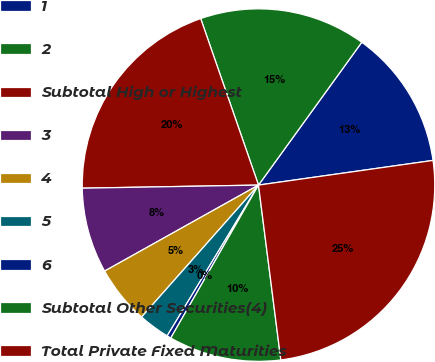Convert chart. <chart><loc_0><loc_0><loc_500><loc_500><pie_chart><fcel>1<fcel>2<fcel>Subtotal High or Highest<fcel>3<fcel>4<fcel>5<fcel>6<fcel>Subtotal Other Securities(4)<fcel>Total Private Fixed Maturities<nl><fcel>12.8%<fcel>15.28%<fcel>19.96%<fcel>7.83%<fcel>5.35%<fcel>2.87%<fcel>0.38%<fcel>10.31%<fcel>25.21%<nl></chart> 